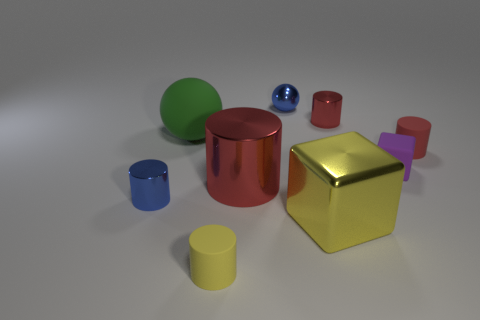How many red cylinders must be subtracted to get 1 red cylinders? 2 Subtract all cyan blocks. How many red cylinders are left? 3 Subtract all blue cylinders. How many cylinders are left? 4 Subtract all blue cylinders. How many cylinders are left? 4 Subtract all brown cylinders. Subtract all blue cubes. How many cylinders are left? 5 Add 1 yellow cylinders. How many objects exist? 10 Subtract all balls. How many objects are left? 7 Subtract 1 yellow cubes. How many objects are left? 8 Subtract all purple matte things. Subtract all brown cubes. How many objects are left? 8 Add 8 green matte balls. How many green matte balls are left? 9 